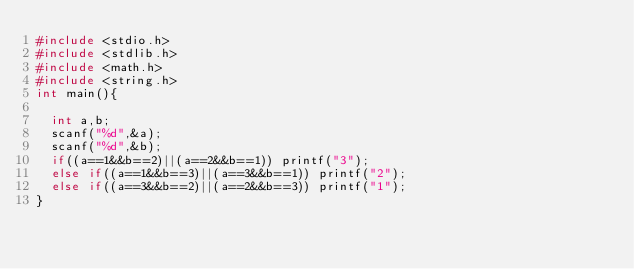Convert code to text. <code><loc_0><loc_0><loc_500><loc_500><_C_>#include <stdio.h>
#include <stdlib.h>
#include <math.h>
#include <string.h>
int main(){

  int a,b;
  scanf("%d",&a);
  scanf("%d",&b);
  if((a==1&&b==2)||(a==2&&b==1)) printf("3");
  else if((a==1&&b==3)||(a==3&&b==1)) printf("2");
  else if((a==3&&b==2)||(a==2&&b==3)) printf("1");
}</code> 